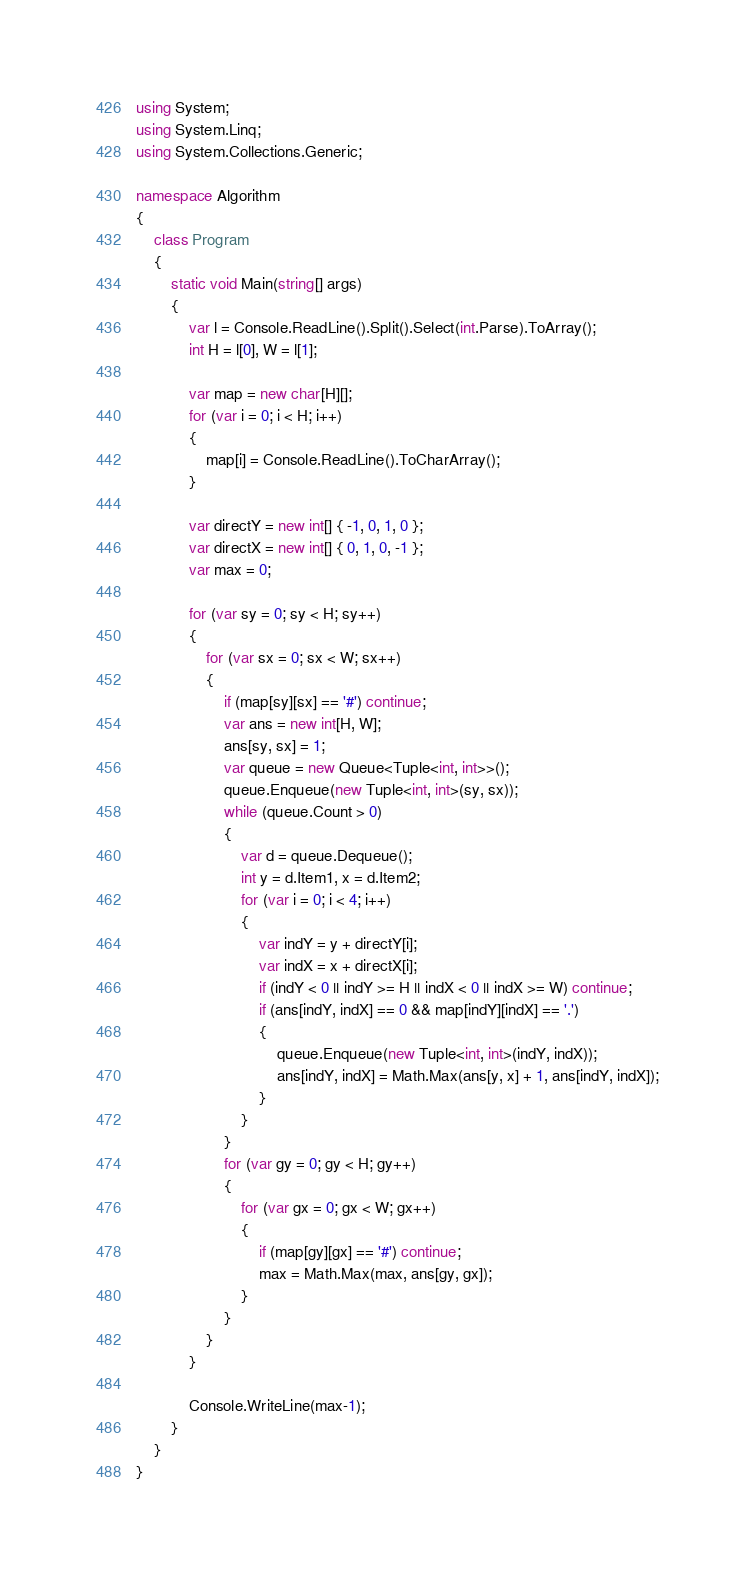<code> <loc_0><loc_0><loc_500><loc_500><_C#_>using System;
using System.Linq;
using System.Collections.Generic;

namespace Algorithm
{
    class Program
    {
        static void Main(string[] args)
        {
            var l = Console.ReadLine().Split().Select(int.Parse).ToArray();
            int H = l[0], W = l[1];

            var map = new char[H][];
            for (var i = 0; i < H; i++)
            {
                map[i] = Console.ReadLine().ToCharArray();
            }

            var directY = new int[] { -1, 0, 1, 0 };
            var directX = new int[] { 0, 1, 0, -1 };
            var max = 0;

            for (var sy = 0; sy < H; sy++)
            {
                for (var sx = 0; sx < W; sx++)
                {
                    if (map[sy][sx] == '#') continue;
                    var ans = new int[H, W];
                    ans[sy, sx] = 1;
                    var queue = new Queue<Tuple<int, int>>();
                    queue.Enqueue(new Tuple<int, int>(sy, sx));
                    while (queue.Count > 0)
                    {
                        var d = queue.Dequeue();
                        int y = d.Item1, x = d.Item2;
                        for (var i = 0; i < 4; i++)
                        {
                            var indY = y + directY[i];
                            var indX = x + directX[i];
                            if (indY < 0 || indY >= H || indX < 0 || indX >= W) continue;
                            if (ans[indY, indX] == 0 && map[indY][indX] == '.')
                            {
                                queue.Enqueue(new Tuple<int, int>(indY, indX));
                                ans[indY, indX] = Math.Max(ans[y, x] + 1, ans[indY, indX]);
                            }
                        }
                    }
                    for (var gy = 0; gy < H; gy++)
                    {
                        for (var gx = 0; gx < W; gx++)
                        {
                            if (map[gy][gx] == '#') continue;
                            max = Math.Max(max, ans[gy, gx]);
                        }
                    }
                }
            }

            Console.WriteLine(max-1);
        }
    }
}</code> 